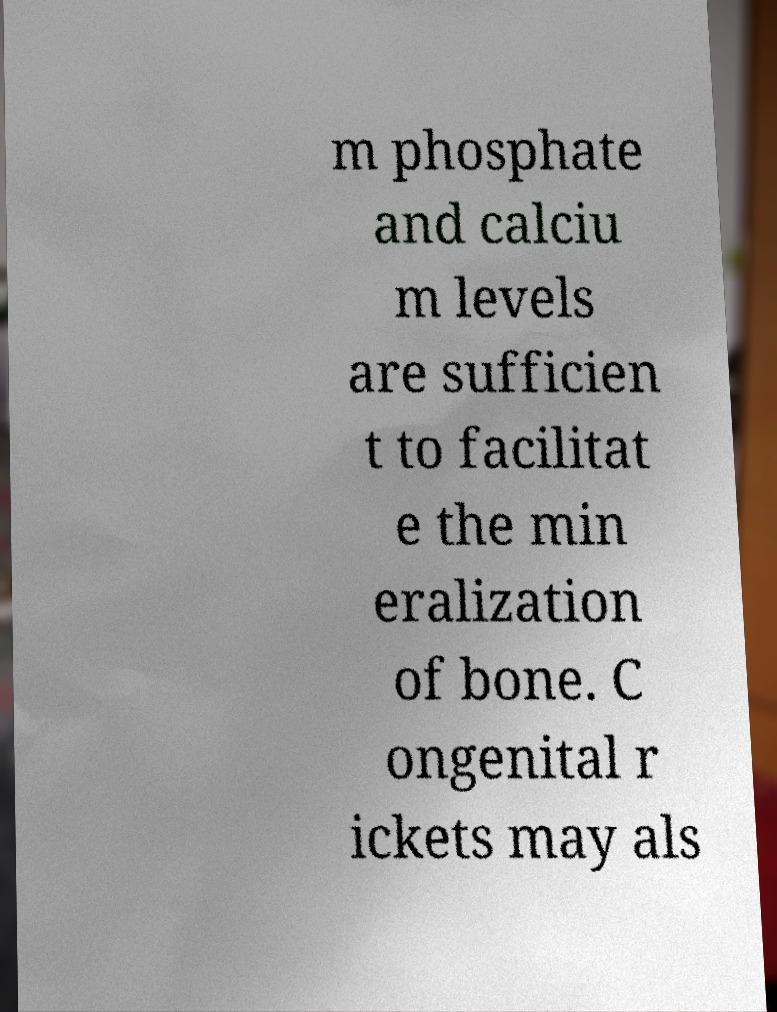Please identify and transcribe the text found in this image. m phosphate and calciu m levels are sufficien t to facilitat e the min eralization of bone. C ongenital r ickets may als 